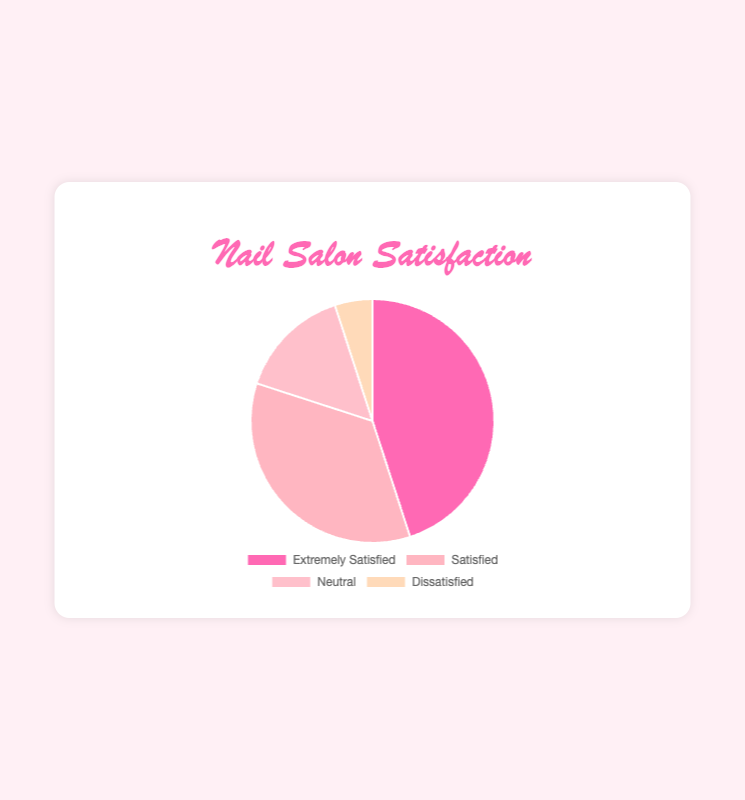What percentage of customers were either Extremely Satisfied or Satisfied? Add the values for Extremely Satisfied (45) and Satisfied (35). The total is 45 + 35 = 80. So, 80% of customers were either Extremely Satisfied or Satisfied.
Answer: 80% Which category of customers is the smallest in percentage? The category with the smallest value is Dissatisfied, which has 5% of the customers.
Answer: Dissatisfied What is the difference in percentage between Satisfied and Neutral customers? Subtract the value of Neutral (15) from the value of Satisfied (35). The difference is 35 - 15 = 20.
Answer: 20% How many more people are Extremely Satisfied compared to Dissatisfied? Subtract the value of Dissatisfied (5) from the value of Extremely Satisfied (45). The difference is 45 - 5 = 40.
Answer: 40 What fraction of the customers are Neutral? 15 out of the total 100 customers are Neutral. So the fraction is 15/100, which simplifies to 3/20.
Answer: 3/20 Which two categories combined make up exactly half of the total responses? The categories Neutral (15) and Satisfied (35) together make up 15 + 35 = 50, which is half of the total 100 responses.
Answer: Neutral and Satisfied Compared to Neutral customers, how many more customers were satisfied? Subtract the number of Neutral customers (15) from the number of Satisfied customers (35). The result is 35 - 15 = 20.
Answer: 20 Which category has the highest percentage? The category with the highest value is Extremely Satisfied, which accounts for 45% of the customers.
Answer: Extremely Satisfied 